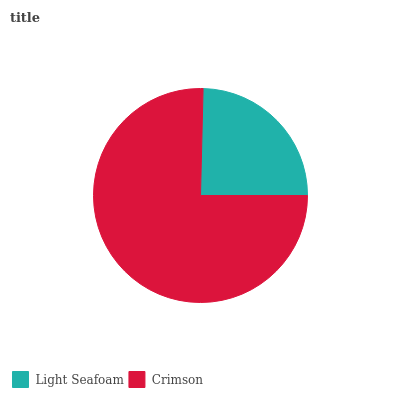Is Light Seafoam the minimum?
Answer yes or no. Yes. Is Crimson the maximum?
Answer yes or no. Yes. Is Crimson the minimum?
Answer yes or no. No. Is Crimson greater than Light Seafoam?
Answer yes or no. Yes. Is Light Seafoam less than Crimson?
Answer yes or no. Yes. Is Light Seafoam greater than Crimson?
Answer yes or no. No. Is Crimson less than Light Seafoam?
Answer yes or no. No. Is Crimson the high median?
Answer yes or no. Yes. Is Light Seafoam the low median?
Answer yes or no. Yes. Is Light Seafoam the high median?
Answer yes or no. No. Is Crimson the low median?
Answer yes or no. No. 